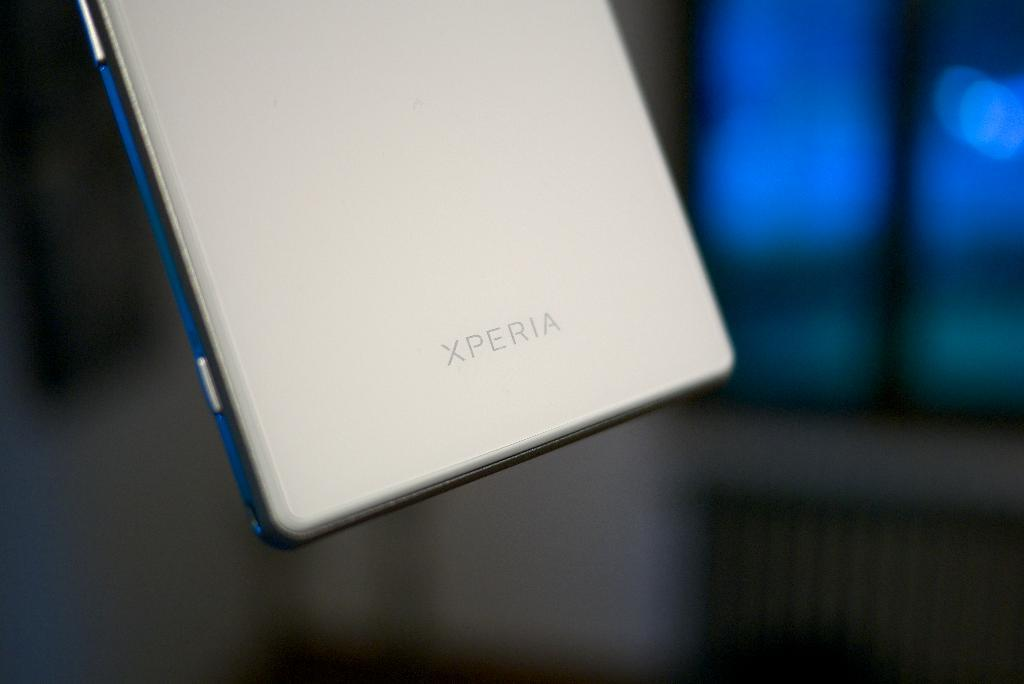What is the main object in the image? There is a mobile in the image. Can you describe the mobile in more detail? Unfortunately, the provided facts do not offer any additional details about the mobile. Where is the mobile located in the image? The facts do not specify the location of the mobile within the image. What type of silk is used to make the mobile's strings? There is no mention of silk or strings in the provided facts, so it is impossible to determine the material used for the mobile's strings. 